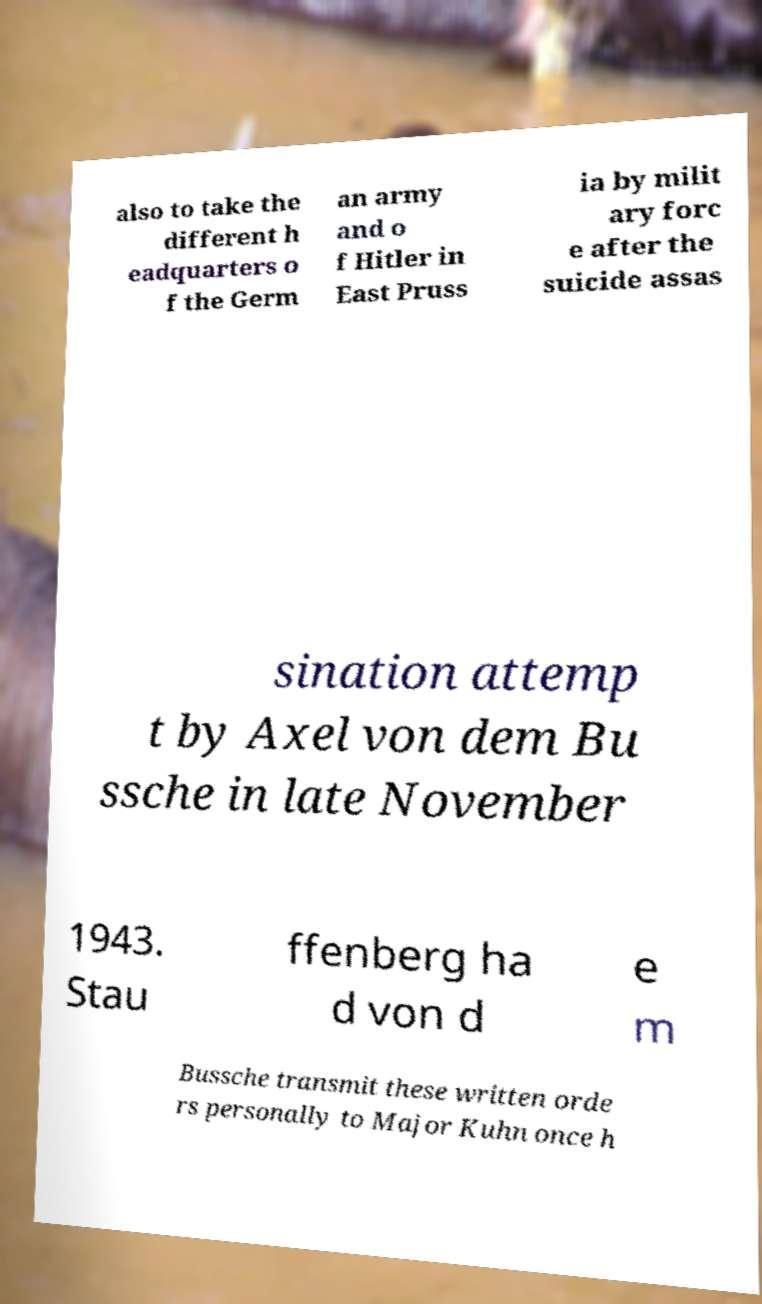Can you accurately transcribe the text from the provided image for me? also to take the different h eadquarters o f the Germ an army and o f Hitler in East Pruss ia by milit ary forc e after the suicide assas sination attemp t by Axel von dem Bu ssche in late November 1943. Stau ffenberg ha d von d e m Bussche transmit these written orde rs personally to Major Kuhn once h 